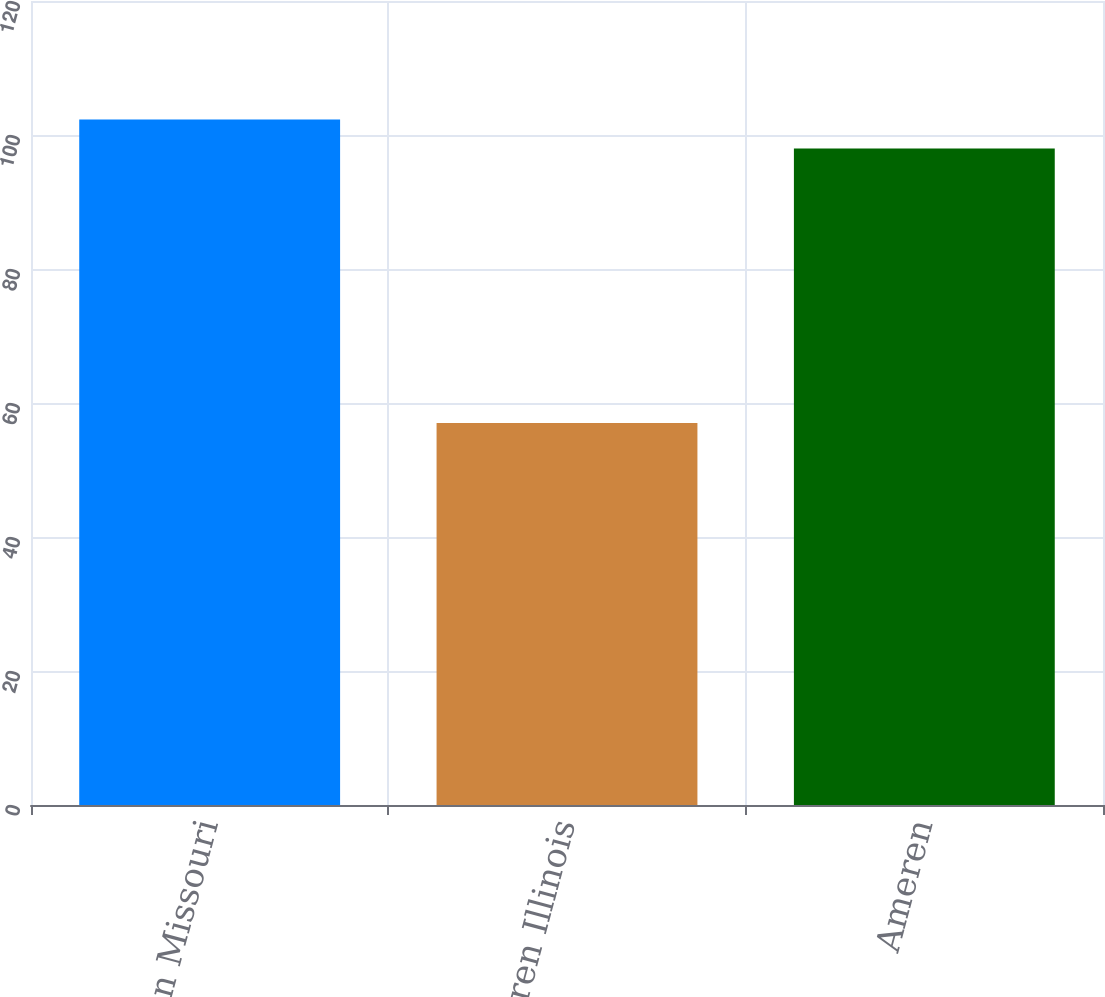Convert chart. <chart><loc_0><loc_0><loc_500><loc_500><bar_chart><fcel>Ameren Missouri<fcel>Ameren Illinois<fcel>Ameren<nl><fcel>102.3<fcel>57<fcel>98<nl></chart> 